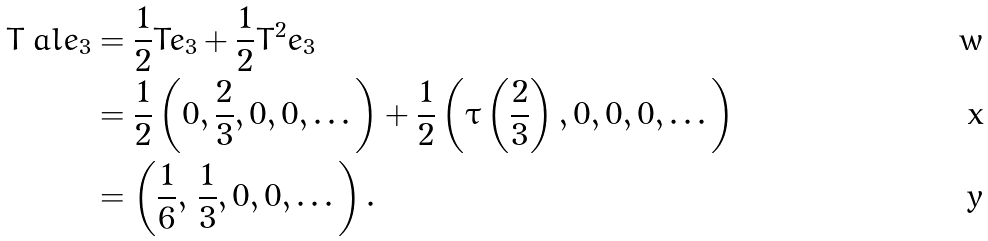Convert formula to latex. <formula><loc_0><loc_0><loc_500><loc_500>T _ { \ } a l e _ { 3 } & = \frac { 1 } { 2 } T e _ { 3 } + \frac { 1 } { 2 } T ^ { 2 } e _ { 3 } \\ & = \frac { 1 } { 2 } \left ( 0 , \frac { 2 } { 3 } , 0 , 0 , \dots \right ) + \frac { 1 } { 2 } \left ( \tau \left ( \frac { 2 } { 3 } \right ) , 0 , 0 , 0 , \dots \right ) \\ & = \left ( \frac { 1 } { 6 } , \, \frac { 1 } { 3 } , 0 , 0 , \dots \right ) .</formula> 